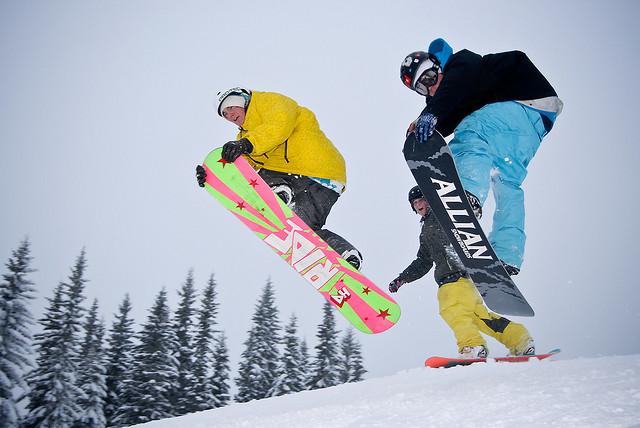What is the weather like?
Be succinct. Cold. What word is on the bottom of the skies?
Short answer required. Alliance. How many snowboarders are there?
Concise answer only. 3. What is in the background?
Be succinct. Trees. What is the man doing?
Give a very brief answer. Snowboarding. Do they both have goggles?
Answer briefly. No. What is the gender of the person in front?
Keep it brief. Male. Is the man testing his board?
Short answer required. Yes. How many ski poles is the person holding?
Quick response, please. 0. What are the doing?
Keep it brief. Snowboarding. What game is the person playing?
Give a very brief answer. Snowboarding. Are all three snowboarders attempting a stunt in unison?
Give a very brief answer. No. 